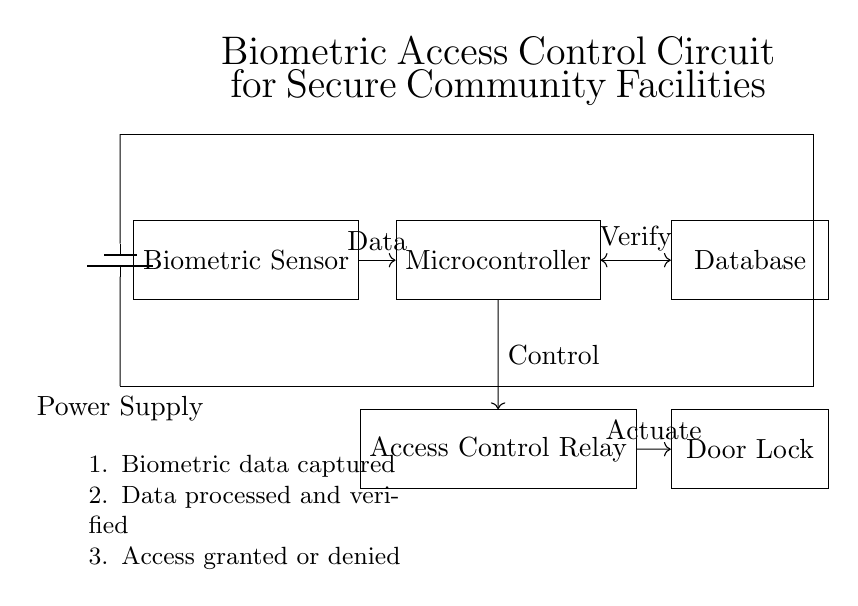What is the main function of the biometric sensor? The biometric sensor's main function is to capture biometric data from individuals, such as fingerprints or facial recognition, for identity verification.
Answer: Capture biometric data What component is responsible for controlling access? The Access Control Relay is the component responsible for controlling access based on the signals it receives from the microcontroller.
Answer: Access Control Relay How does the microcontroller interact with the database? The microcontroller interacts with the database through a verification process where it sends the captured biometric data to check if it matches any stored records.
Answer: Verify What is the role of the door lock in this circuit? The door lock's role is to physically secure the entrance by either locking or unlocking it, depending on the control signal received from the access control relay.
Answer: Secure the entrance How many main components are in the circuit? There are five main components in the circuit: the biometric sensor, microcontroller, database, access control relay, and door lock.
Answer: Five What initiates the process of granting or denying access? The process is initiated by the biometric data being captured by the sensor and sent to the microcontroller for processing and verification.
Answer: Biometric data captured What type of power source is used in this circuit? This circuit uses a battery as the power source, which provides the necessary energy for all the components to operate.
Answer: Battery 